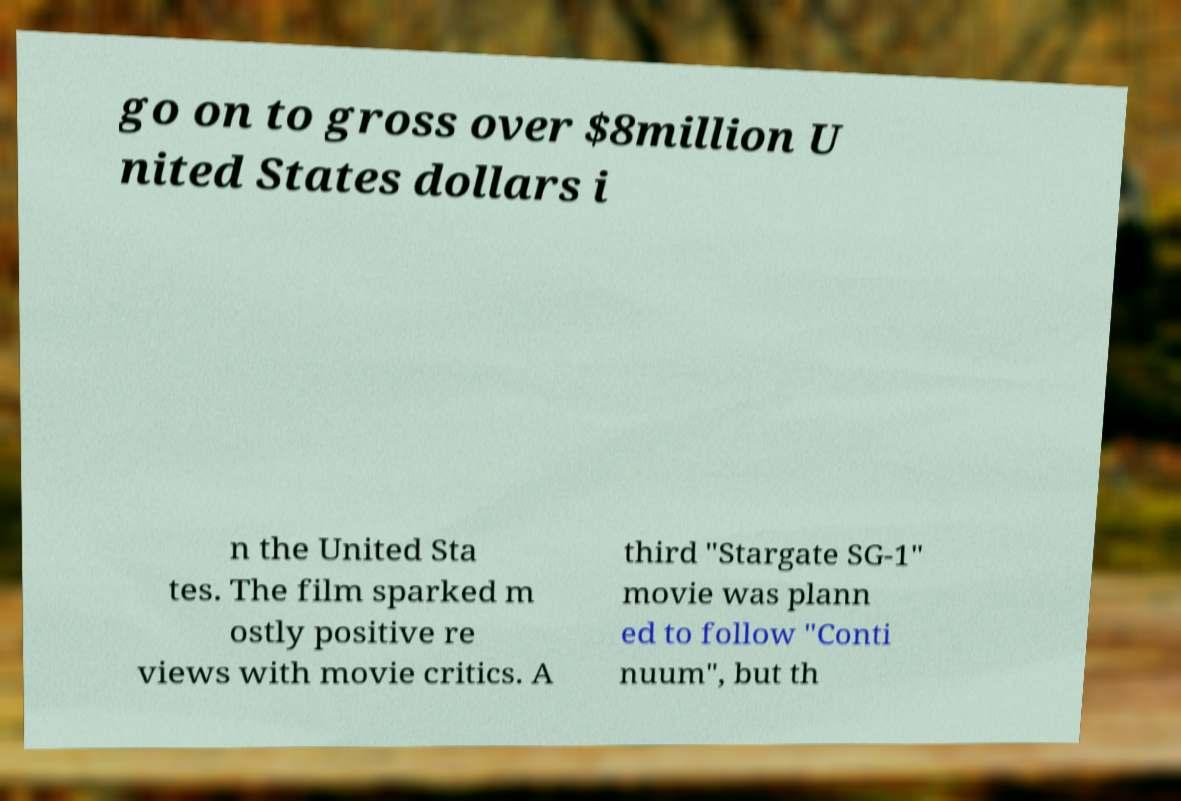Could you extract and type out the text from this image? go on to gross over $8million U nited States dollars i n the United Sta tes. The film sparked m ostly positive re views with movie critics. A third "Stargate SG-1" movie was plann ed to follow "Conti nuum", but th 